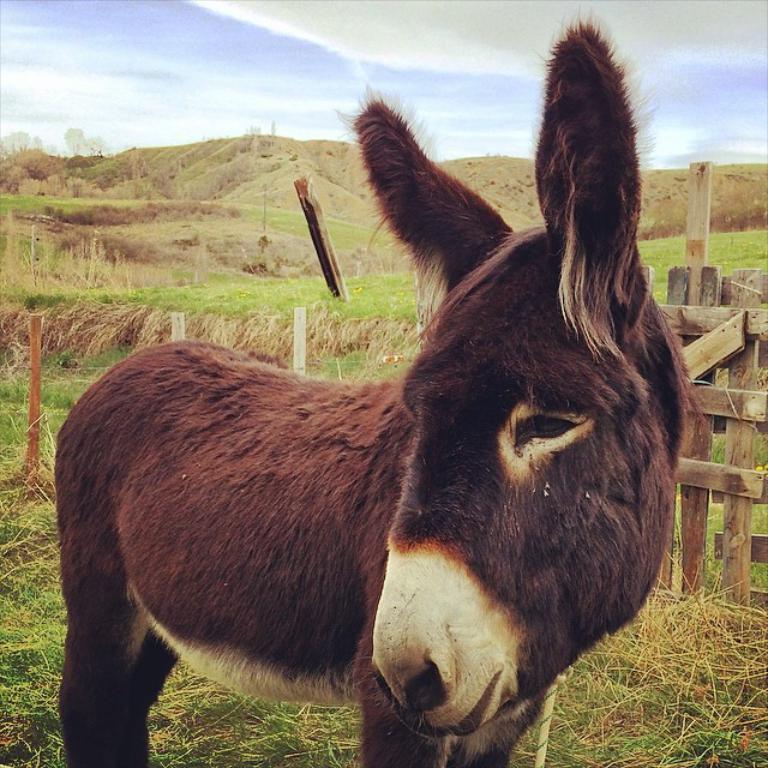Can you describe this image briefly? In this image in the foreground there is a donkey, and in the background there is a fence, grass and mountains and some rods. At the bottom there is grass, at the top there is sky. 